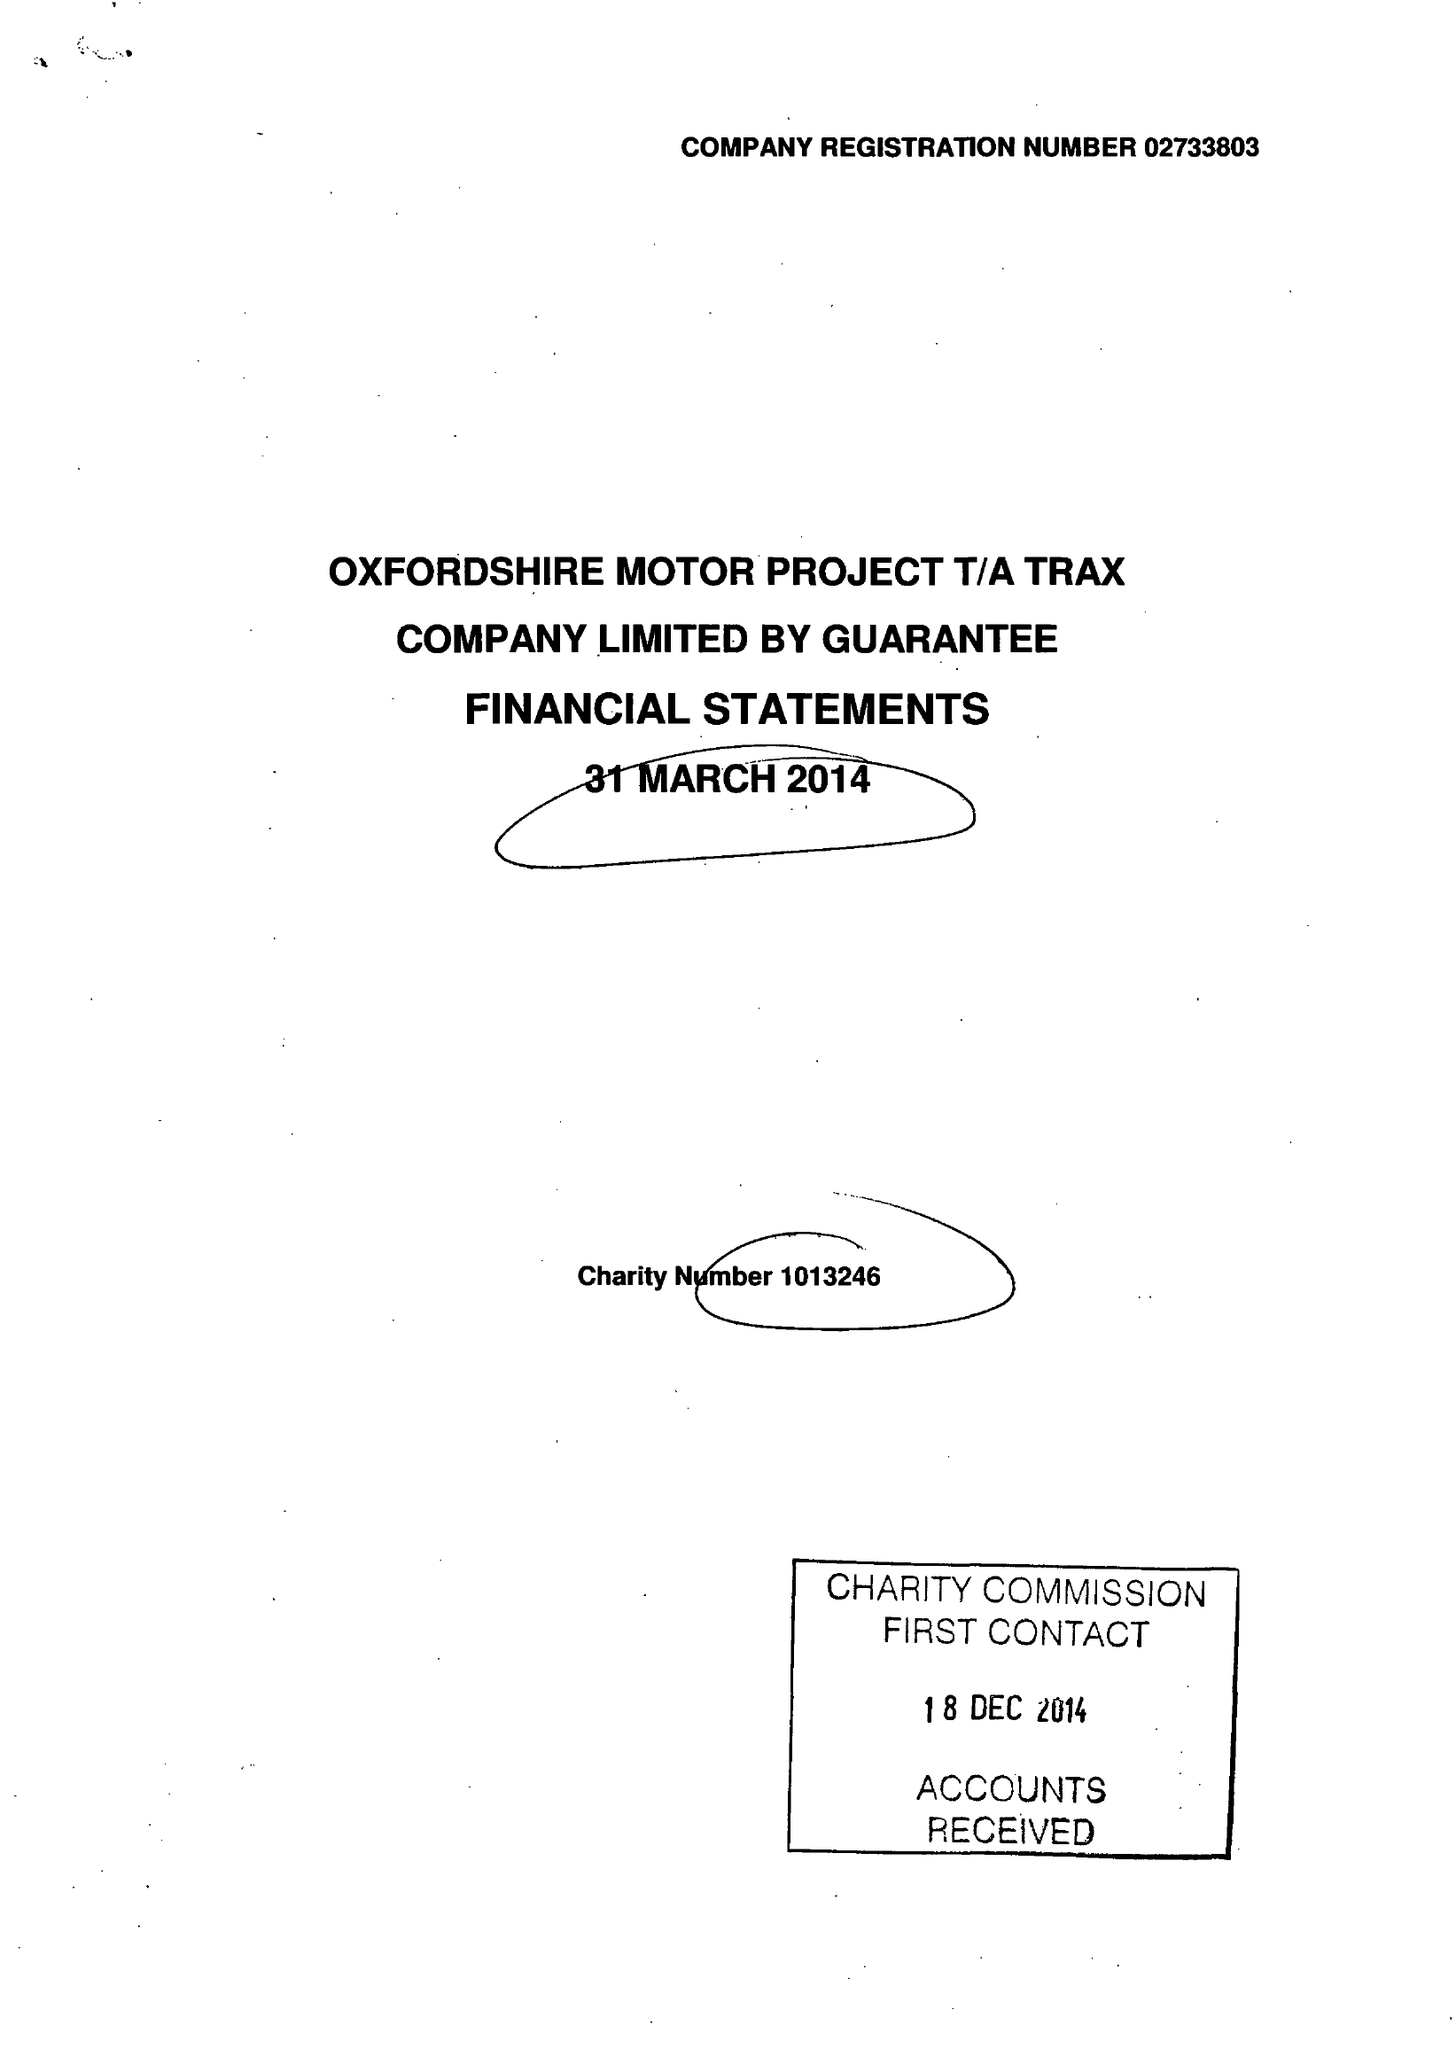What is the value for the charity_name?
Answer the question using a single word or phrase. Oxfordshire Motor Project 